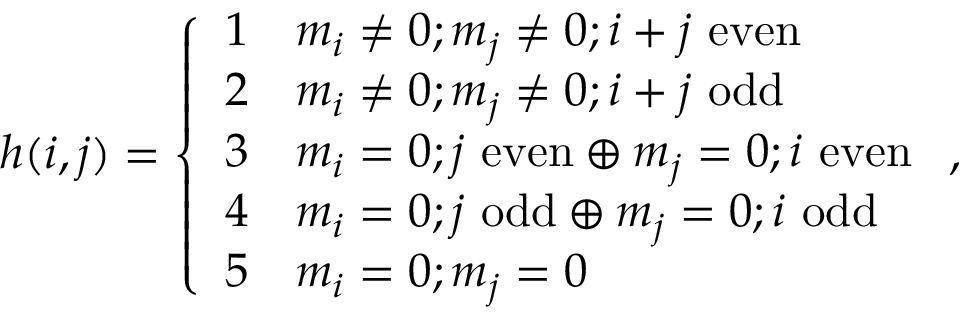Convert formula to latex. <formula><loc_0><loc_0><loc_500><loc_500>h ( i , j ) = \left \{ \begin{array} { l l } { 1 } & { m _ { i } \neq 0 ; m _ { j } \neq 0 ; i + j e v e n } \\ { 2 } & { m _ { i } \neq 0 ; m _ { j } \neq 0 ; i + j o d d } \\ { 3 } & { m _ { i } = 0 ; j e v e n \oplus m _ { j } = 0 ; i e v e n } \\ { 4 } & { m _ { i } = 0 ; j o d d \oplus m _ { j } = 0 ; i o d d } \\ { 5 } & { m _ { i } = 0 ; m _ { j } = 0 } \end{array} ,</formula> 